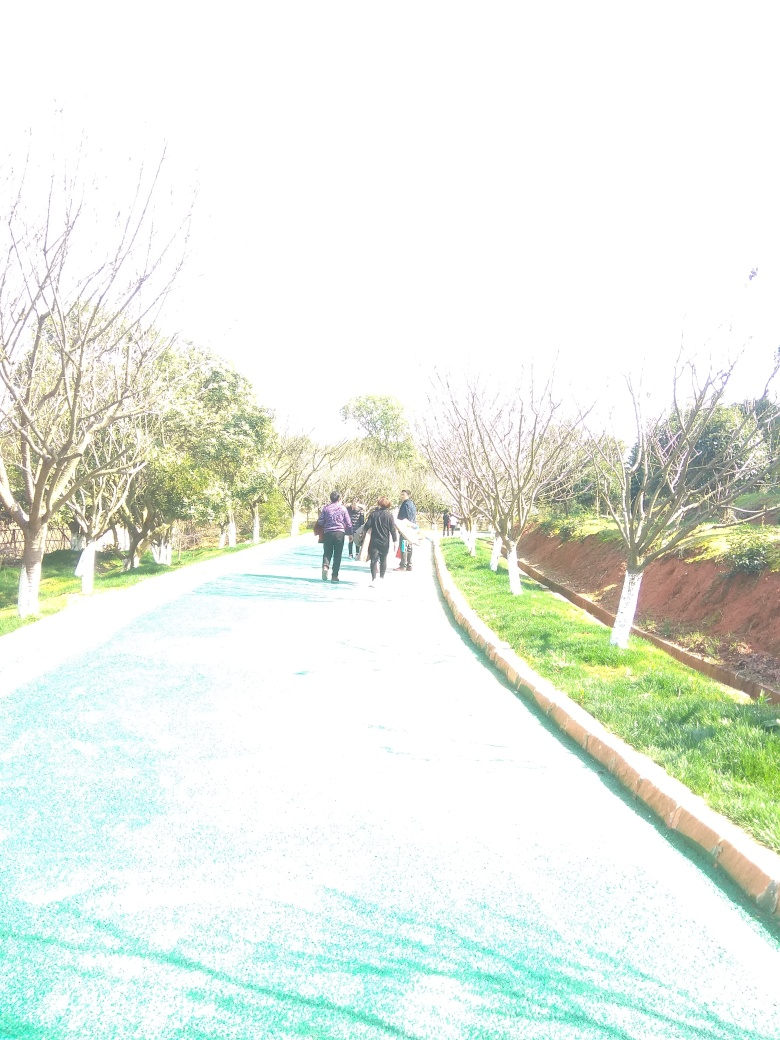How could the overexposed areas of this photo be corrected in post-processing? Overexposed areas can be adjusted through photo editing software by decreasing the exposure, increasing the contrast, and sometimes using the 'highlights' slider to recover some details. However, if the area is completely blown out, meaning all color information is lost, it may be impossible to recover significant detail. Using graduated filters or localized adjustments can help target and correct specific overexposed regions. 